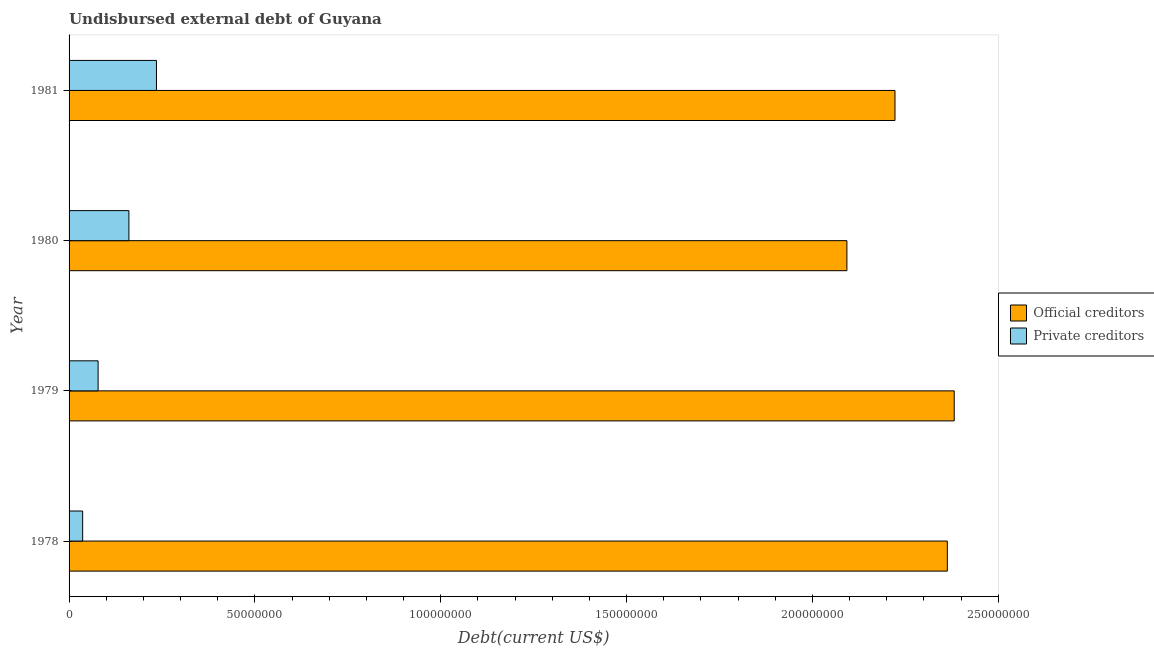How many bars are there on the 4th tick from the top?
Your answer should be very brief. 2. How many bars are there on the 4th tick from the bottom?
Keep it short and to the point. 2. What is the label of the 1st group of bars from the top?
Give a very brief answer. 1981. What is the undisbursed external debt of official creditors in 1981?
Make the answer very short. 2.22e+08. Across all years, what is the maximum undisbursed external debt of official creditors?
Give a very brief answer. 2.38e+08. Across all years, what is the minimum undisbursed external debt of official creditors?
Provide a succinct answer. 2.09e+08. In which year was the undisbursed external debt of official creditors maximum?
Make the answer very short. 1979. In which year was the undisbursed external debt of private creditors minimum?
Provide a succinct answer. 1978. What is the total undisbursed external debt of private creditors in the graph?
Give a very brief answer. 5.11e+07. What is the difference between the undisbursed external debt of private creditors in 1978 and that in 1981?
Offer a very short reply. -1.99e+07. What is the difference between the undisbursed external debt of official creditors in 1981 and the undisbursed external debt of private creditors in 1979?
Offer a very short reply. 2.14e+08. What is the average undisbursed external debt of official creditors per year?
Make the answer very short. 2.26e+08. In the year 1981, what is the difference between the undisbursed external debt of private creditors and undisbursed external debt of official creditors?
Keep it short and to the point. -1.99e+08. In how many years, is the undisbursed external debt of private creditors greater than 30000000 US$?
Provide a short and direct response. 0. What is the ratio of the undisbursed external debt of official creditors in 1979 to that in 1980?
Ensure brevity in your answer.  1.14. Is the difference between the undisbursed external debt of official creditors in 1980 and 1981 greater than the difference between the undisbursed external debt of private creditors in 1980 and 1981?
Make the answer very short. No. What is the difference between the highest and the second highest undisbursed external debt of private creditors?
Your answer should be compact. 7.42e+06. What is the difference between the highest and the lowest undisbursed external debt of official creditors?
Your response must be concise. 2.89e+07. What does the 1st bar from the top in 1981 represents?
Offer a very short reply. Private creditors. What does the 2nd bar from the bottom in 1980 represents?
Make the answer very short. Private creditors. How many bars are there?
Your answer should be compact. 8. Are all the bars in the graph horizontal?
Give a very brief answer. Yes. How many years are there in the graph?
Keep it short and to the point. 4. Does the graph contain grids?
Your response must be concise. No. How are the legend labels stacked?
Your answer should be compact. Vertical. What is the title of the graph?
Ensure brevity in your answer.  Undisbursed external debt of Guyana. What is the label or title of the X-axis?
Your answer should be compact. Debt(current US$). What is the Debt(current US$) in Official creditors in 1978?
Provide a succinct answer. 2.36e+08. What is the Debt(current US$) in Private creditors in 1978?
Offer a terse response. 3.66e+06. What is the Debt(current US$) of Official creditors in 1979?
Your response must be concise. 2.38e+08. What is the Debt(current US$) in Private creditors in 1979?
Make the answer very short. 7.81e+06. What is the Debt(current US$) in Official creditors in 1980?
Your response must be concise. 2.09e+08. What is the Debt(current US$) of Private creditors in 1980?
Your answer should be very brief. 1.61e+07. What is the Debt(current US$) in Official creditors in 1981?
Provide a short and direct response. 2.22e+08. What is the Debt(current US$) in Private creditors in 1981?
Keep it short and to the point. 2.35e+07. Across all years, what is the maximum Debt(current US$) of Official creditors?
Keep it short and to the point. 2.38e+08. Across all years, what is the maximum Debt(current US$) in Private creditors?
Offer a terse response. 2.35e+07. Across all years, what is the minimum Debt(current US$) in Official creditors?
Keep it short and to the point. 2.09e+08. Across all years, what is the minimum Debt(current US$) in Private creditors?
Ensure brevity in your answer.  3.66e+06. What is the total Debt(current US$) of Official creditors in the graph?
Offer a terse response. 9.06e+08. What is the total Debt(current US$) of Private creditors in the graph?
Make the answer very short. 5.11e+07. What is the difference between the Debt(current US$) in Official creditors in 1978 and that in 1979?
Provide a succinct answer. -1.86e+06. What is the difference between the Debt(current US$) in Private creditors in 1978 and that in 1979?
Your answer should be compact. -4.15e+06. What is the difference between the Debt(current US$) of Official creditors in 1978 and that in 1980?
Your response must be concise. 2.70e+07. What is the difference between the Debt(current US$) in Private creditors in 1978 and that in 1980?
Make the answer very short. -1.24e+07. What is the difference between the Debt(current US$) of Official creditors in 1978 and that in 1981?
Offer a very short reply. 1.41e+07. What is the difference between the Debt(current US$) in Private creditors in 1978 and that in 1981?
Your answer should be very brief. -1.99e+07. What is the difference between the Debt(current US$) of Official creditors in 1979 and that in 1980?
Your response must be concise. 2.89e+07. What is the difference between the Debt(current US$) of Private creditors in 1979 and that in 1980?
Make the answer very short. -8.29e+06. What is the difference between the Debt(current US$) in Official creditors in 1979 and that in 1981?
Provide a short and direct response. 1.59e+07. What is the difference between the Debt(current US$) of Private creditors in 1979 and that in 1981?
Your answer should be very brief. -1.57e+07. What is the difference between the Debt(current US$) in Official creditors in 1980 and that in 1981?
Your answer should be compact. -1.29e+07. What is the difference between the Debt(current US$) in Private creditors in 1980 and that in 1981?
Your response must be concise. -7.42e+06. What is the difference between the Debt(current US$) of Official creditors in 1978 and the Debt(current US$) of Private creditors in 1979?
Offer a terse response. 2.28e+08. What is the difference between the Debt(current US$) in Official creditors in 1978 and the Debt(current US$) in Private creditors in 1980?
Your answer should be very brief. 2.20e+08. What is the difference between the Debt(current US$) of Official creditors in 1978 and the Debt(current US$) of Private creditors in 1981?
Offer a terse response. 2.13e+08. What is the difference between the Debt(current US$) of Official creditors in 1979 and the Debt(current US$) of Private creditors in 1980?
Provide a short and direct response. 2.22e+08. What is the difference between the Debt(current US$) of Official creditors in 1979 and the Debt(current US$) of Private creditors in 1981?
Give a very brief answer. 2.15e+08. What is the difference between the Debt(current US$) of Official creditors in 1980 and the Debt(current US$) of Private creditors in 1981?
Provide a short and direct response. 1.86e+08. What is the average Debt(current US$) in Official creditors per year?
Provide a short and direct response. 2.26e+08. What is the average Debt(current US$) in Private creditors per year?
Make the answer very short. 1.28e+07. In the year 1978, what is the difference between the Debt(current US$) of Official creditors and Debt(current US$) of Private creditors?
Offer a terse response. 2.33e+08. In the year 1979, what is the difference between the Debt(current US$) of Official creditors and Debt(current US$) of Private creditors?
Keep it short and to the point. 2.30e+08. In the year 1980, what is the difference between the Debt(current US$) of Official creditors and Debt(current US$) of Private creditors?
Give a very brief answer. 1.93e+08. In the year 1981, what is the difference between the Debt(current US$) in Official creditors and Debt(current US$) in Private creditors?
Provide a succinct answer. 1.99e+08. What is the ratio of the Debt(current US$) in Private creditors in 1978 to that in 1979?
Provide a short and direct response. 0.47. What is the ratio of the Debt(current US$) of Official creditors in 1978 to that in 1980?
Your answer should be very brief. 1.13. What is the ratio of the Debt(current US$) of Private creditors in 1978 to that in 1980?
Make the answer very short. 0.23. What is the ratio of the Debt(current US$) of Official creditors in 1978 to that in 1981?
Provide a short and direct response. 1.06. What is the ratio of the Debt(current US$) in Private creditors in 1978 to that in 1981?
Your answer should be compact. 0.16. What is the ratio of the Debt(current US$) of Official creditors in 1979 to that in 1980?
Your response must be concise. 1.14. What is the ratio of the Debt(current US$) in Private creditors in 1979 to that in 1980?
Your answer should be very brief. 0.49. What is the ratio of the Debt(current US$) of Official creditors in 1979 to that in 1981?
Provide a succinct answer. 1.07. What is the ratio of the Debt(current US$) of Private creditors in 1979 to that in 1981?
Offer a terse response. 0.33. What is the ratio of the Debt(current US$) in Official creditors in 1980 to that in 1981?
Your answer should be very brief. 0.94. What is the ratio of the Debt(current US$) in Private creditors in 1980 to that in 1981?
Provide a succinct answer. 0.68. What is the difference between the highest and the second highest Debt(current US$) in Official creditors?
Provide a succinct answer. 1.86e+06. What is the difference between the highest and the second highest Debt(current US$) of Private creditors?
Offer a very short reply. 7.42e+06. What is the difference between the highest and the lowest Debt(current US$) in Official creditors?
Your response must be concise. 2.89e+07. What is the difference between the highest and the lowest Debt(current US$) in Private creditors?
Provide a short and direct response. 1.99e+07. 